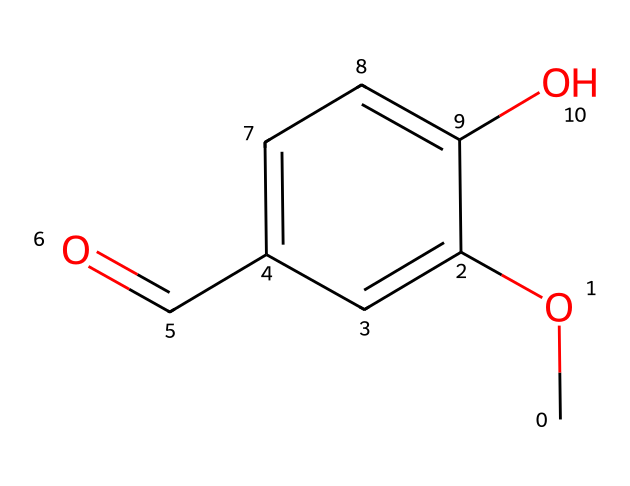What is the molecular formula of vanillin? The molecular formula can be determined by counting the number of each type of atom in the SMILES representation. The SMILES "COc1cc(C=O)ccc1O" indicates there are 8 carbons (C), 8 hydrogens (H), and 3 oxygens (O), leading to the molecular formula C8H8O3.
Answer: C8H8O3 How many hydroxyl (–OH) groups are present in vanillin? The hydroxyl group can be identified by the "O" in the structure connected to a hydrogen (–OH). Upon examining the SMILES, there is one hydroxyl group indicated by "O" bonded to a carbon.
Answer: 1 What type of functional group does vanillin contain due to the "C=O" in its structure? The "C=O" indicates a carbonyl group, which is a characteristic of aldehydes in this case. The presence of "C=O" along with "H" further confirms that the compound is an aldehyde.
Answer: aldehyde Is vanillin a phenolic compound? To determine if it is phenolic, we look for the presence of a benzene ring and a hydroxyl group (–OH) in the structure. The presence of the benzene-like structure and the –OH confirms that it is indeed a phenolic compound.
Answer: yes How many rings are present in the structure of vanillin? The SMILES representation shows a benzene ring structure, recognizable by the alternating double bonds, which indicates that there is one cyclic structure in vanillin.
Answer: 1 What is the aromaticity status of the benzene ring in vanillin? The aromatic ring is indicated by the alternating single and double bonds as shown in the SMILES. The presence of a complete cyclic structure with conjugated pi bonds confirms that the ring is aromatic.
Answer: aromatic 